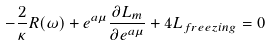Convert formula to latex. <formula><loc_0><loc_0><loc_500><loc_500>- \frac { 2 } { \kappa } R ( \omega ) + e ^ { a \mu } \frac { \partial L _ { m } } { \partial e ^ { a \mu } } + 4 L _ { f r e e z i n g } = 0</formula> 